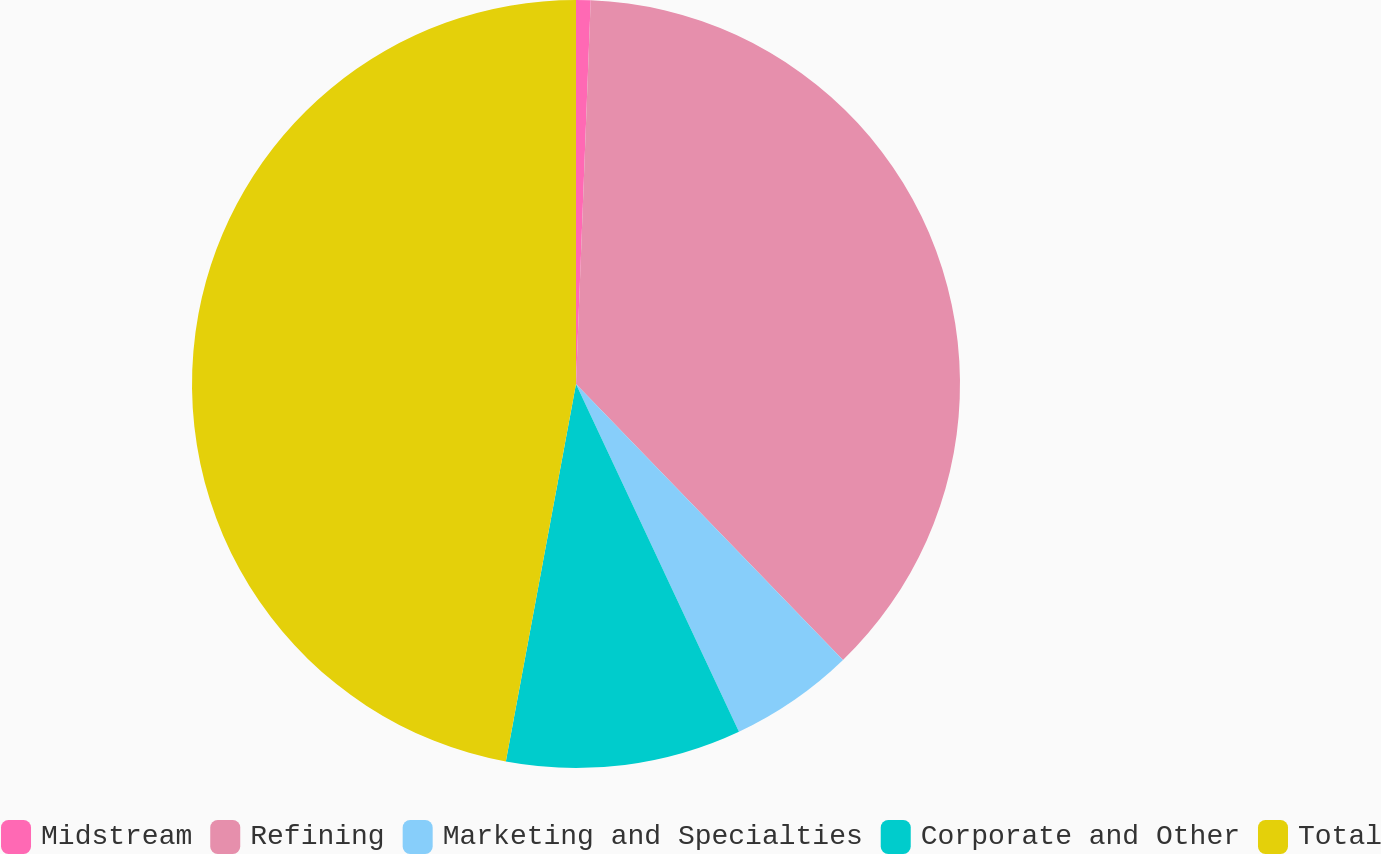Convert chart to OTSL. <chart><loc_0><loc_0><loc_500><loc_500><pie_chart><fcel>Midstream<fcel>Refining<fcel>Marketing and Specialties<fcel>Corporate and Other<fcel>Total<nl><fcel>0.61%<fcel>37.15%<fcel>5.26%<fcel>9.9%<fcel>47.07%<nl></chart> 